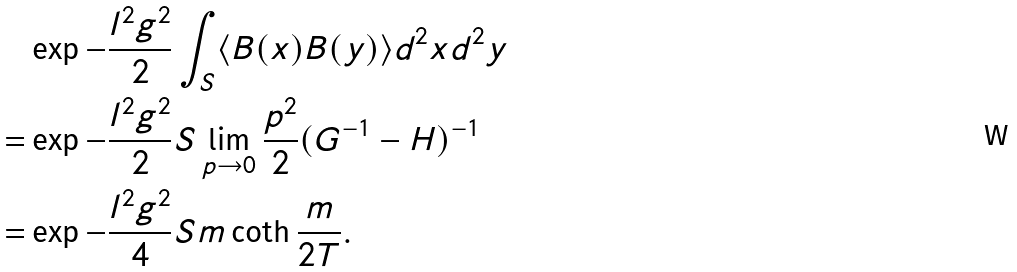Convert formula to latex. <formula><loc_0><loc_0><loc_500><loc_500>& \exp { - \frac { l ^ { 2 } g ^ { 2 } } { 2 } \int _ { S } \langle B ( x ) B ( y ) \rangle d ^ { 2 } x d ^ { 2 } y } \\ = & \exp { - \frac { l ^ { 2 } g ^ { 2 } } { 2 } S \lim _ { p \rightarrow 0 } \frac { p ^ { 2 } } { 2 } ( G ^ { - 1 } - H ) ^ { - 1 } } \\ = & \exp { - \frac { l ^ { 2 } g ^ { 2 } } { 4 } S m \coth \frac { m } { 2 T } } .</formula> 